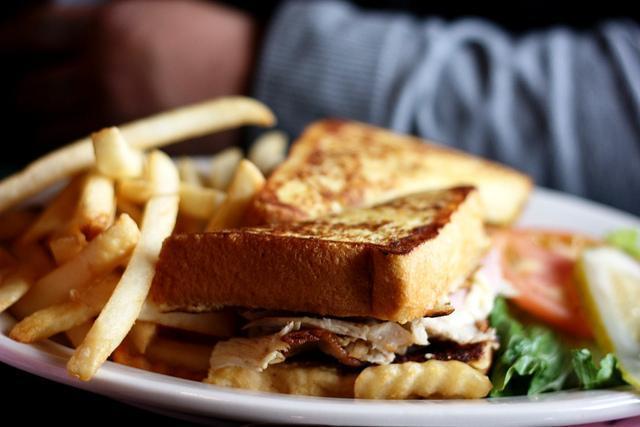How many vegetables are on the plate?
Give a very brief answer. 3. How many sandwiches are in the picture?
Give a very brief answer. 2. 